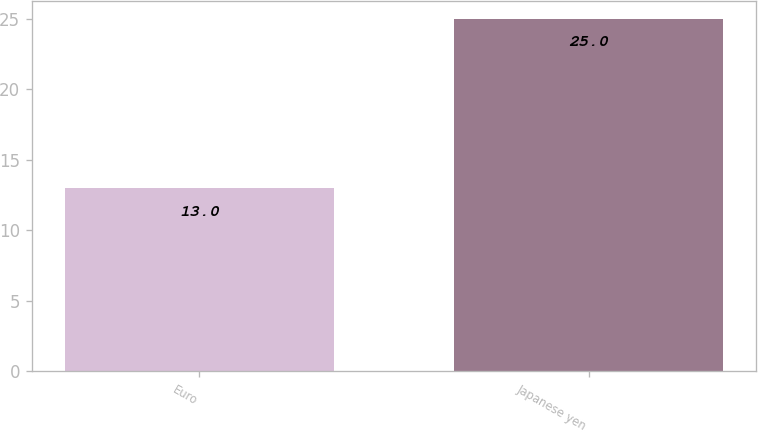Convert chart. <chart><loc_0><loc_0><loc_500><loc_500><bar_chart><fcel>Euro<fcel>Japanese yen<nl><fcel>13<fcel>25<nl></chart> 